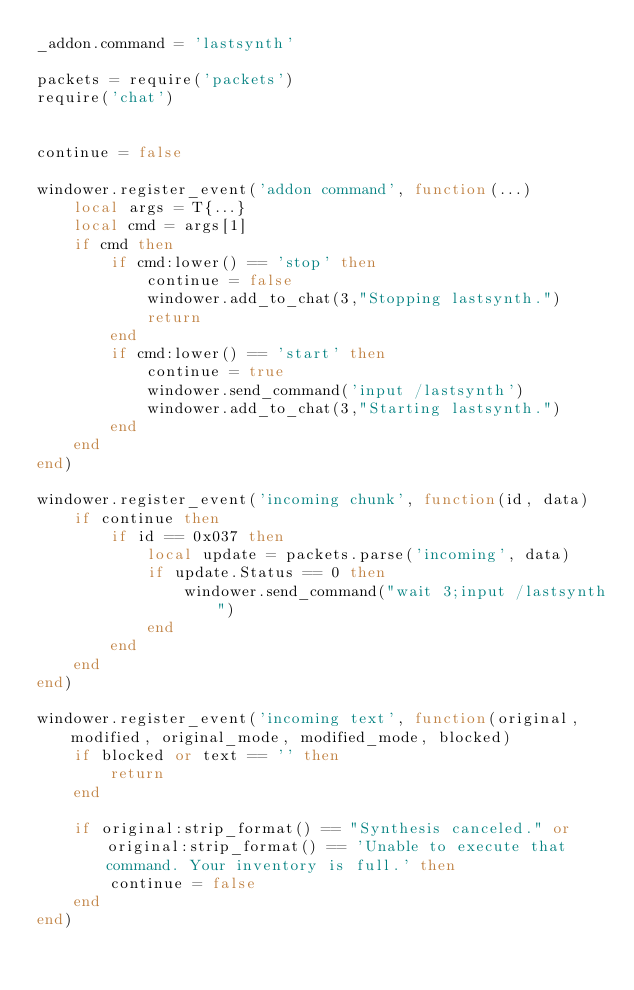Convert code to text. <code><loc_0><loc_0><loc_500><loc_500><_Lua_>_addon.command = 'lastsynth'

packets = require('packets')
require('chat')


continue = false

windower.register_event('addon command', function(...)
	local args = T{...}
	local cmd = args[1]
	if cmd then 
		if cmd:lower() == 'stop' then
			continue = false
            windower.add_to_chat(3,"Stopping lastsynth.")
            return
		end
        if cmd:lower() == 'start' then
            continue = true
            windower.send_command('input /lastsynth')
            windower.add_to_chat(3,"Starting lastsynth.")
        end
    end
end)

windower.register_event('incoming chunk', function(id, data)
    if continue then
        if id == 0x037 then 
            local update = packets.parse('incoming', data)
            if update.Status == 0 then
                windower.send_command("wait 3;input /lastsynth")
            end
        end
    end
end)

windower.register_event('incoming text', function(original, modified, original_mode, modified_mode, blocked)
    if blocked or text == '' then
        return
    end

	if original:strip_format() == "Synthesis canceled." or original:strip_format() == 'Unable to execute that command. Your inventory is full.' then
		continue = false
	end
end)</code> 